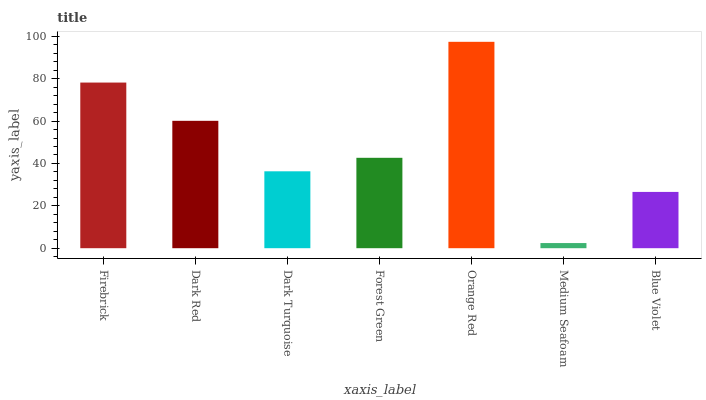Is Medium Seafoam the minimum?
Answer yes or no. Yes. Is Orange Red the maximum?
Answer yes or no. Yes. Is Dark Red the minimum?
Answer yes or no. No. Is Dark Red the maximum?
Answer yes or no. No. Is Firebrick greater than Dark Red?
Answer yes or no. Yes. Is Dark Red less than Firebrick?
Answer yes or no. Yes. Is Dark Red greater than Firebrick?
Answer yes or no. No. Is Firebrick less than Dark Red?
Answer yes or no. No. Is Forest Green the high median?
Answer yes or no. Yes. Is Forest Green the low median?
Answer yes or no. Yes. Is Dark Red the high median?
Answer yes or no. No. Is Blue Violet the low median?
Answer yes or no. No. 